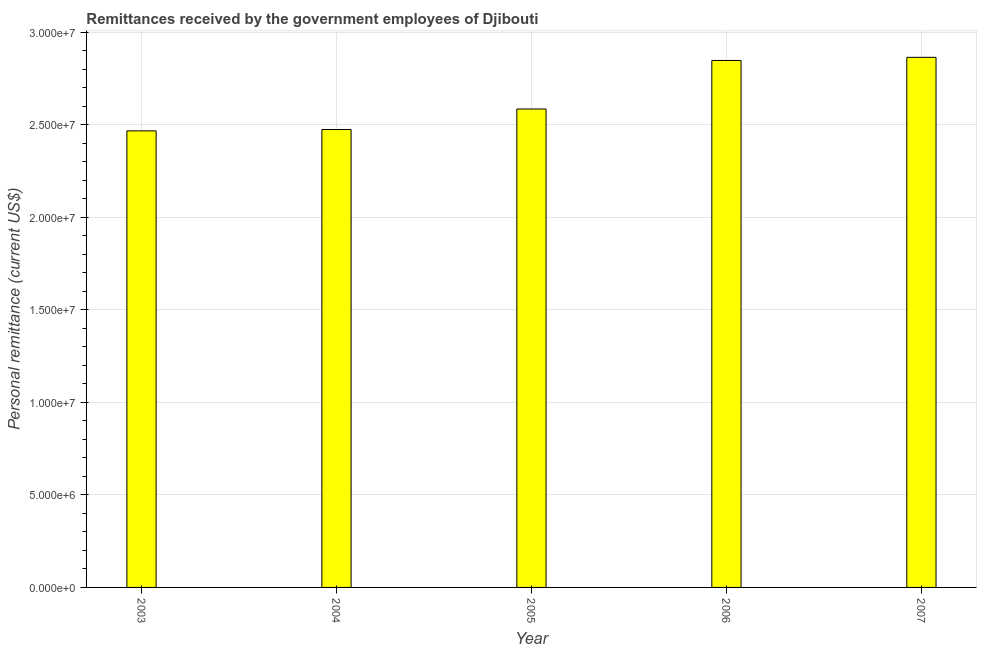Does the graph contain grids?
Offer a terse response. Yes. What is the title of the graph?
Ensure brevity in your answer.  Remittances received by the government employees of Djibouti. What is the label or title of the Y-axis?
Ensure brevity in your answer.  Personal remittance (current US$). What is the personal remittances in 2003?
Your answer should be compact. 2.47e+07. Across all years, what is the maximum personal remittances?
Provide a succinct answer. 2.86e+07. Across all years, what is the minimum personal remittances?
Your response must be concise. 2.47e+07. What is the sum of the personal remittances?
Provide a short and direct response. 1.32e+08. What is the difference between the personal remittances in 2004 and 2007?
Ensure brevity in your answer.  -3.90e+06. What is the average personal remittances per year?
Provide a short and direct response. 2.65e+07. What is the median personal remittances?
Your answer should be very brief. 2.58e+07. Do a majority of the years between 2003 and 2005 (inclusive) have personal remittances greater than 23000000 US$?
Give a very brief answer. Yes. What is the ratio of the personal remittances in 2004 to that in 2007?
Your answer should be compact. 0.86. Is the personal remittances in 2003 less than that in 2007?
Ensure brevity in your answer.  Yes. What is the difference between the highest and the second highest personal remittances?
Offer a very short reply. 1.69e+05. Is the sum of the personal remittances in 2005 and 2007 greater than the maximum personal remittances across all years?
Keep it short and to the point. Yes. What is the difference between the highest and the lowest personal remittances?
Give a very brief answer. 3.97e+06. In how many years, is the personal remittances greater than the average personal remittances taken over all years?
Make the answer very short. 2. How many bars are there?
Keep it short and to the point. 5. Are all the bars in the graph horizontal?
Provide a short and direct response. No. How many years are there in the graph?
Your response must be concise. 5. What is the Personal remittance (current US$) in 2003?
Your response must be concise. 2.47e+07. What is the Personal remittance (current US$) of 2004?
Ensure brevity in your answer.  2.47e+07. What is the Personal remittance (current US$) of 2005?
Offer a very short reply. 2.58e+07. What is the Personal remittance (current US$) of 2006?
Make the answer very short. 2.85e+07. What is the Personal remittance (current US$) in 2007?
Your answer should be compact. 2.86e+07. What is the difference between the Personal remittance (current US$) in 2003 and 2004?
Your answer should be very brief. -7.31e+04. What is the difference between the Personal remittance (current US$) in 2003 and 2005?
Provide a succinct answer. -1.18e+06. What is the difference between the Personal remittance (current US$) in 2003 and 2006?
Offer a very short reply. -3.80e+06. What is the difference between the Personal remittance (current US$) in 2003 and 2007?
Ensure brevity in your answer.  -3.97e+06. What is the difference between the Personal remittance (current US$) in 2004 and 2005?
Your answer should be compact. -1.11e+06. What is the difference between the Personal remittance (current US$) in 2004 and 2006?
Offer a very short reply. -3.73e+06. What is the difference between the Personal remittance (current US$) in 2004 and 2007?
Give a very brief answer. -3.90e+06. What is the difference between the Personal remittance (current US$) in 2005 and 2006?
Provide a succinct answer. -2.62e+06. What is the difference between the Personal remittance (current US$) in 2005 and 2007?
Keep it short and to the point. -2.79e+06. What is the difference between the Personal remittance (current US$) in 2006 and 2007?
Ensure brevity in your answer.  -1.69e+05. What is the ratio of the Personal remittance (current US$) in 2003 to that in 2004?
Make the answer very short. 1. What is the ratio of the Personal remittance (current US$) in 2003 to that in 2005?
Provide a succinct answer. 0.95. What is the ratio of the Personal remittance (current US$) in 2003 to that in 2006?
Offer a very short reply. 0.87. What is the ratio of the Personal remittance (current US$) in 2003 to that in 2007?
Your answer should be very brief. 0.86. What is the ratio of the Personal remittance (current US$) in 2004 to that in 2005?
Offer a terse response. 0.96. What is the ratio of the Personal remittance (current US$) in 2004 to that in 2006?
Offer a terse response. 0.87. What is the ratio of the Personal remittance (current US$) in 2004 to that in 2007?
Your answer should be compact. 0.86. What is the ratio of the Personal remittance (current US$) in 2005 to that in 2006?
Your answer should be very brief. 0.91. What is the ratio of the Personal remittance (current US$) in 2005 to that in 2007?
Make the answer very short. 0.9. What is the ratio of the Personal remittance (current US$) in 2006 to that in 2007?
Provide a short and direct response. 0.99. 